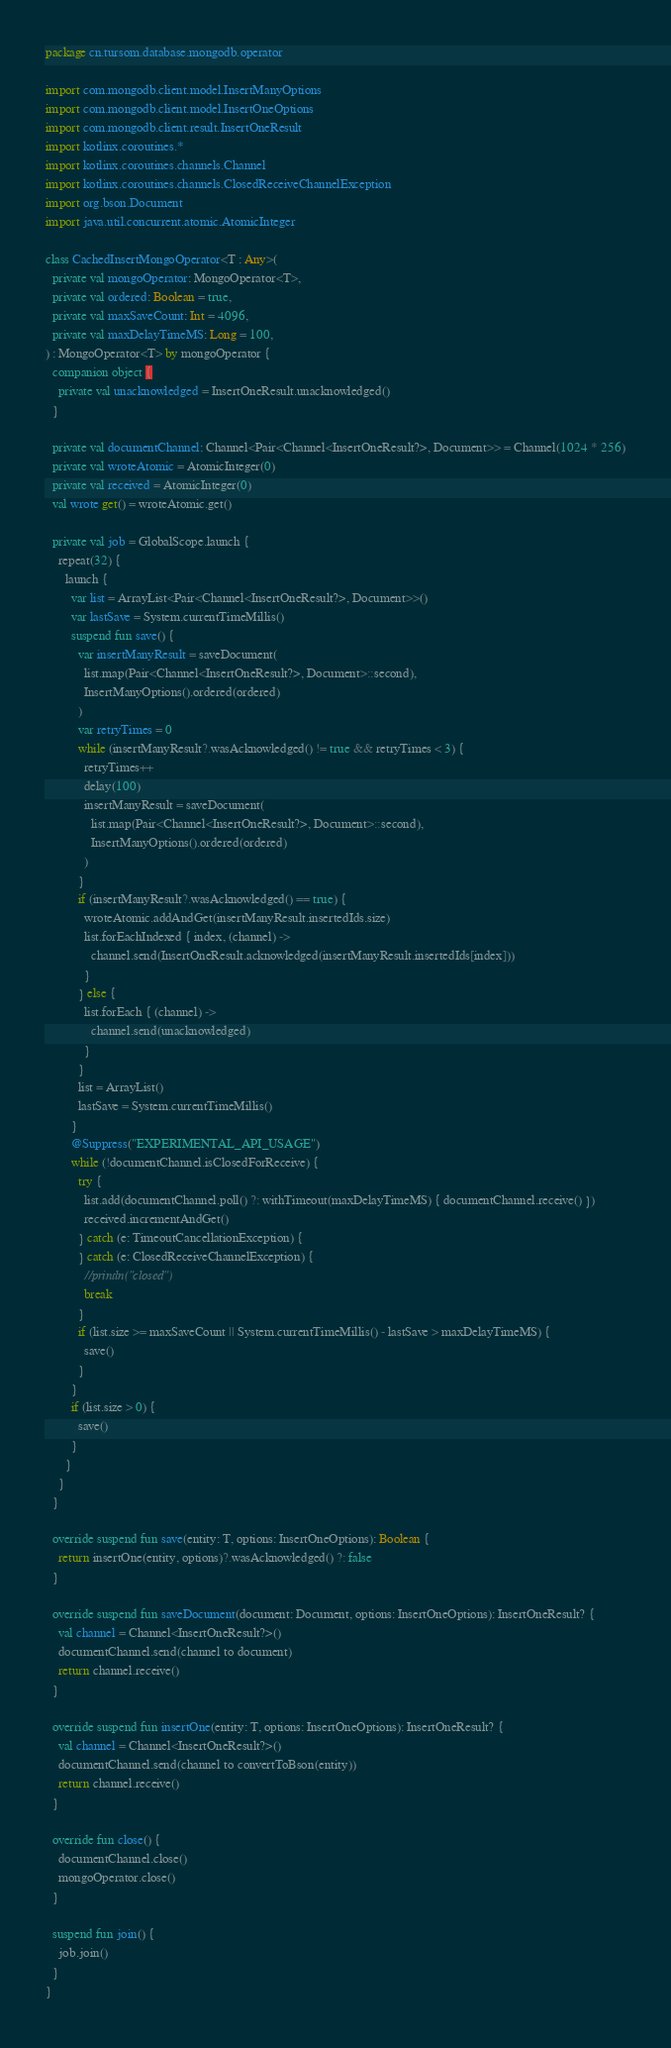Convert code to text. <code><loc_0><loc_0><loc_500><loc_500><_Kotlin_>package cn.tursom.database.mongodb.operator

import com.mongodb.client.model.InsertManyOptions
import com.mongodb.client.model.InsertOneOptions
import com.mongodb.client.result.InsertOneResult
import kotlinx.coroutines.*
import kotlinx.coroutines.channels.Channel
import kotlinx.coroutines.channels.ClosedReceiveChannelException
import org.bson.Document
import java.util.concurrent.atomic.AtomicInteger

class CachedInsertMongoOperator<T : Any>(
  private val mongoOperator: MongoOperator<T>,
  private val ordered: Boolean = true,
  private val maxSaveCount: Int = 4096,
  private val maxDelayTimeMS: Long = 100,
) : MongoOperator<T> by mongoOperator {
  companion object {
    private val unacknowledged = InsertOneResult.unacknowledged()
  }

  private val documentChannel: Channel<Pair<Channel<InsertOneResult?>, Document>> = Channel(1024 * 256)
  private val wroteAtomic = AtomicInteger(0)
  private val received = AtomicInteger(0)
  val wrote get() = wroteAtomic.get()

  private val job = GlobalScope.launch {
    repeat(32) {
      launch {
        var list = ArrayList<Pair<Channel<InsertOneResult?>, Document>>()
        var lastSave = System.currentTimeMillis()
        suspend fun save() {
          var insertManyResult = saveDocument(
            list.map(Pair<Channel<InsertOneResult?>, Document>::second),
            InsertManyOptions().ordered(ordered)
          )
          var retryTimes = 0
          while (insertManyResult?.wasAcknowledged() != true && retryTimes < 3) {
            retryTimes++
            delay(100)
            insertManyResult = saveDocument(
              list.map(Pair<Channel<InsertOneResult?>, Document>::second),
              InsertManyOptions().ordered(ordered)
            )
          }
          if (insertManyResult?.wasAcknowledged() == true) {
            wroteAtomic.addAndGet(insertManyResult.insertedIds.size)
            list.forEachIndexed { index, (channel) ->
              channel.send(InsertOneResult.acknowledged(insertManyResult.insertedIds[index]))
            }
          } else {
            list.forEach { (channel) ->
              channel.send(unacknowledged)
            }
          }
          list = ArrayList()
          lastSave = System.currentTimeMillis()
        }
        @Suppress("EXPERIMENTAL_API_USAGE")
        while (!documentChannel.isClosedForReceive) {
          try {
            list.add(documentChannel.poll() ?: withTimeout(maxDelayTimeMS) { documentChannel.receive() })
            received.incrementAndGet()
          } catch (e: TimeoutCancellationException) {
          } catch (e: ClosedReceiveChannelException) {
            //println("closed")
            break
          }
          if (list.size >= maxSaveCount || System.currentTimeMillis() - lastSave > maxDelayTimeMS) {
            save()
          }
        }
        if (list.size > 0) {
          save()
        }
      }
    }
  }

  override suspend fun save(entity: T, options: InsertOneOptions): Boolean {
    return insertOne(entity, options)?.wasAcknowledged() ?: false
  }

  override suspend fun saveDocument(document: Document, options: InsertOneOptions): InsertOneResult? {
    val channel = Channel<InsertOneResult?>()
    documentChannel.send(channel to document)
    return channel.receive()
  }

  override suspend fun insertOne(entity: T, options: InsertOneOptions): InsertOneResult? {
    val channel = Channel<InsertOneResult?>()
    documentChannel.send(channel to convertToBson(entity))
    return channel.receive()
  }

  override fun close() {
    documentChannel.close()
    mongoOperator.close()
  }

  suspend fun join() {
    job.join()
  }
}</code> 